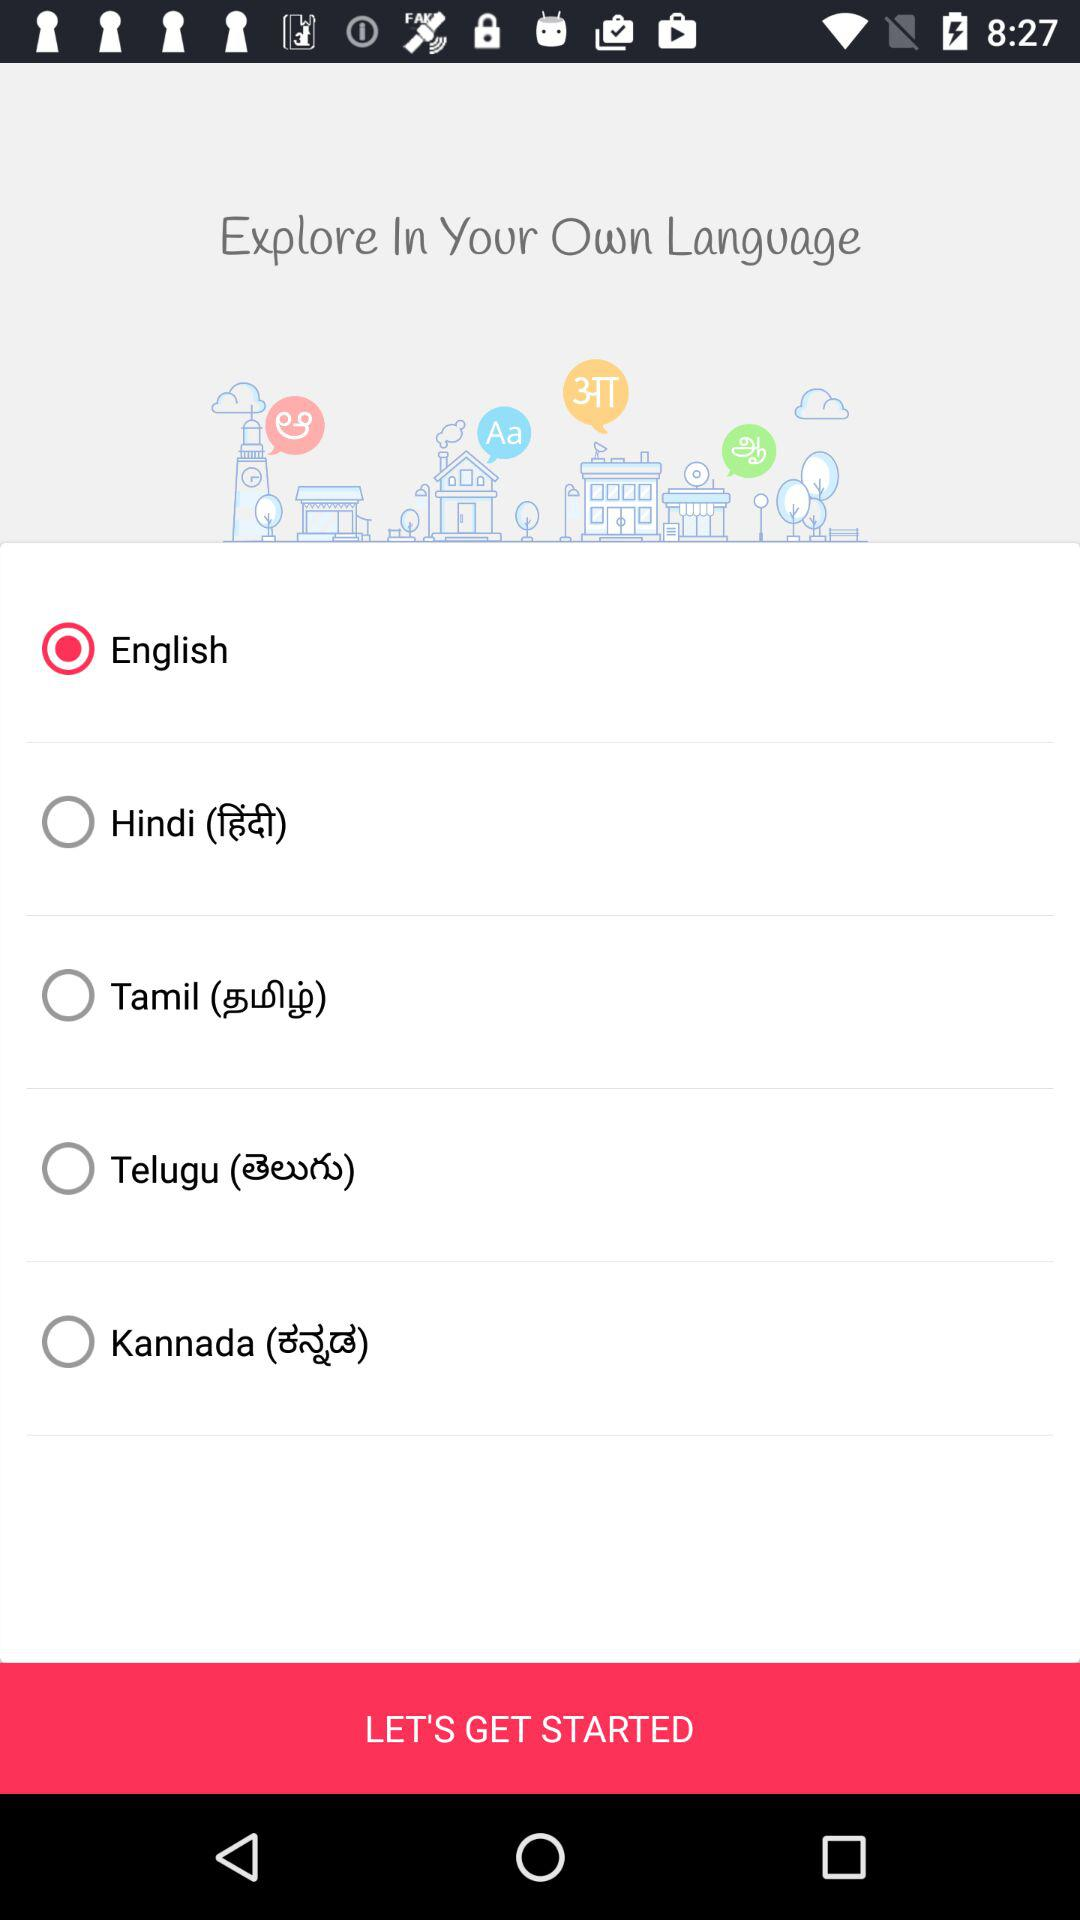How many languages are available to choose from?
Answer the question using a single word or phrase. 5 